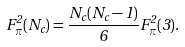<formula> <loc_0><loc_0><loc_500><loc_500>F _ { \pi } ^ { 2 } ( N _ { c } ) = \frac { N _ { c } ( N _ { c } - 1 ) } { 6 } F _ { \pi } ^ { 2 } ( 3 ) .</formula> 